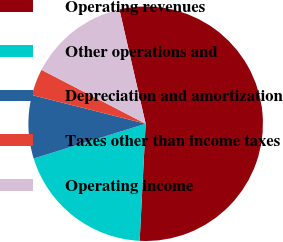Convert chart. <chart><loc_0><loc_0><loc_500><loc_500><pie_chart><fcel>Operating revenues<fcel>Other operations and<fcel>Depreciation and amortization<fcel>Taxes other than income taxes<fcel>Operating income<nl><fcel>54.4%<fcel>19.39%<fcel>8.73%<fcel>3.66%<fcel>13.81%<nl></chart> 